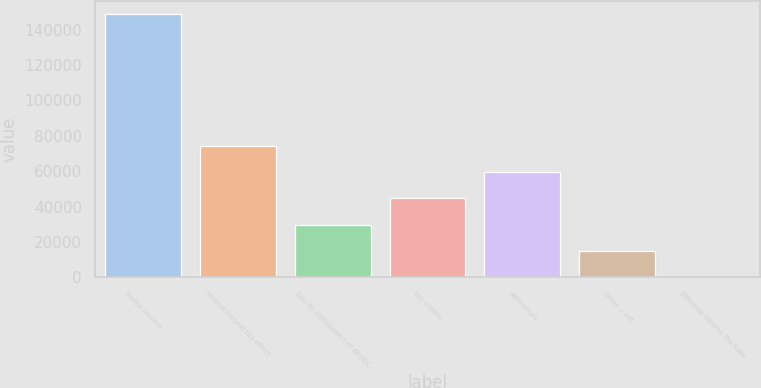<chart> <loc_0><loc_0><loc_500><loc_500><bar_chart><fcel>Pretax income<fcel>federal income tax effect<fcel>Equ ity componen t of AFUDC<fcel>tax credits<fcel>differences<fcel>Other -- net<fcel>Effective Income Tax Rate<nl><fcel>148631<fcel>74343<fcel>29770.2<fcel>44627.8<fcel>59485.4<fcel>14912.6<fcel>55<nl></chart> 